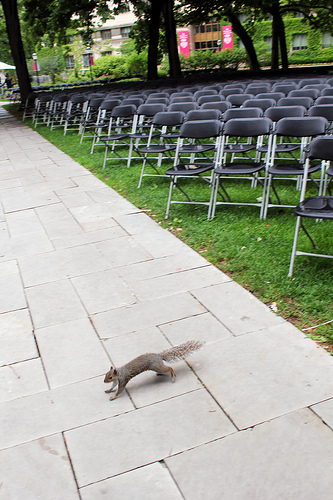<image>
Is there a chair behind the tree? No. The chair is not behind the tree. From this viewpoint, the chair appears to be positioned elsewhere in the scene. 